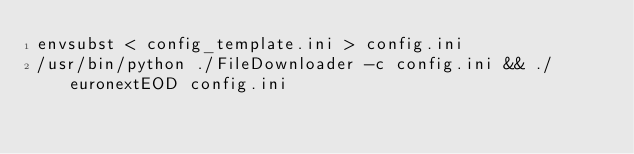Convert code to text. <code><loc_0><loc_0><loc_500><loc_500><_Bash_>envsubst < config_template.ini > config.ini
/usr/bin/python ./FileDownloader -c config.ini && ./euronextEOD config.ini
</code> 